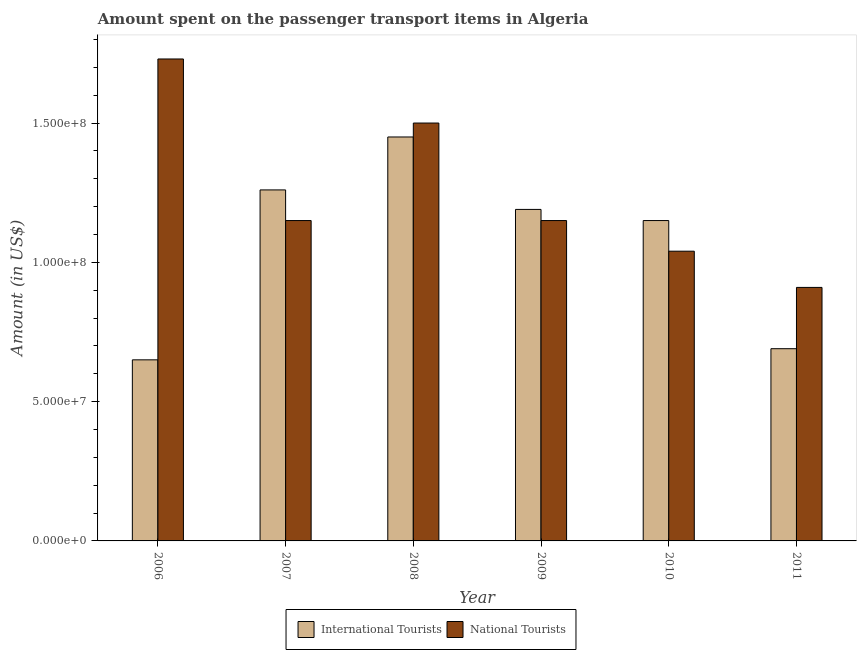How many different coloured bars are there?
Provide a succinct answer. 2. Are the number of bars per tick equal to the number of legend labels?
Ensure brevity in your answer.  Yes. What is the amount spent on transport items of international tourists in 2008?
Your response must be concise. 1.45e+08. Across all years, what is the maximum amount spent on transport items of international tourists?
Make the answer very short. 1.45e+08. Across all years, what is the minimum amount spent on transport items of national tourists?
Keep it short and to the point. 9.10e+07. In which year was the amount spent on transport items of international tourists maximum?
Your response must be concise. 2008. What is the total amount spent on transport items of national tourists in the graph?
Provide a succinct answer. 7.48e+08. What is the difference between the amount spent on transport items of national tourists in 2009 and that in 2011?
Your answer should be compact. 2.40e+07. What is the difference between the amount spent on transport items of international tourists in 2008 and the amount spent on transport items of national tourists in 2007?
Keep it short and to the point. 1.90e+07. What is the average amount spent on transport items of international tourists per year?
Offer a very short reply. 1.06e+08. In how many years, is the amount spent on transport items of national tourists greater than 10000000 US$?
Provide a succinct answer. 6. What is the ratio of the amount spent on transport items of international tourists in 2006 to that in 2007?
Make the answer very short. 0.52. Is the amount spent on transport items of national tourists in 2010 less than that in 2011?
Offer a terse response. No. What is the difference between the highest and the second highest amount spent on transport items of national tourists?
Your answer should be compact. 2.30e+07. What is the difference between the highest and the lowest amount spent on transport items of international tourists?
Keep it short and to the point. 8.00e+07. In how many years, is the amount spent on transport items of international tourists greater than the average amount spent on transport items of international tourists taken over all years?
Ensure brevity in your answer.  4. Is the sum of the amount spent on transport items of international tourists in 2006 and 2007 greater than the maximum amount spent on transport items of national tourists across all years?
Your response must be concise. Yes. What does the 2nd bar from the left in 2009 represents?
Your answer should be compact. National Tourists. What does the 2nd bar from the right in 2007 represents?
Provide a succinct answer. International Tourists. How many years are there in the graph?
Provide a short and direct response. 6. Are the values on the major ticks of Y-axis written in scientific E-notation?
Keep it short and to the point. Yes. Does the graph contain grids?
Provide a succinct answer. No. Where does the legend appear in the graph?
Keep it short and to the point. Bottom center. How many legend labels are there?
Offer a terse response. 2. What is the title of the graph?
Your answer should be compact. Amount spent on the passenger transport items in Algeria. What is the label or title of the X-axis?
Your answer should be compact. Year. What is the label or title of the Y-axis?
Give a very brief answer. Amount (in US$). What is the Amount (in US$) of International Tourists in 2006?
Offer a very short reply. 6.50e+07. What is the Amount (in US$) of National Tourists in 2006?
Offer a very short reply. 1.73e+08. What is the Amount (in US$) in International Tourists in 2007?
Provide a short and direct response. 1.26e+08. What is the Amount (in US$) of National Tourists in 2007?
Make the answer very short. 1.15e+08. What is the Amount (in US$) in International Tourists in 2008?
Ensure brevity in your answer.  1.45e+08. What is the Amount (in US$) in National Tourists in 2008?
Provide a succinct answer. 1.50e+08. What is the Amount (in US$) of International Tourists in 2009?
Offer a very short reply. 1.19e+08. What is the Amount (in US$) in National Tourists in 2009?
Offer a very short reply. 1.15e+08. What is the Amount (in US$) of International Tourists in 2010?
Your answer should be compact. 1.15e+08. What is the Amount (in US$) of National Tourists in 2010?
Make the answer very short. 1.04e+08. What is the Amount (in US$) in International Tourists in 2011?
Keep it short and to the point. 6.90e+07. What is the Amount (in US$) of National Tourists in 2011?
Give a very brief answer. 9.10e+07. Across all years, what is the maximum Amount (in US$) in International Tourists?
Your answer should be very brief. 1.45e+08. Across all years, what is the maximum Amount (in US$) of National Tourists?
Give a very brief answer. 1.73e+08. Across all years, what is the minimum Amount (in US$) of International Tourists?
Offer a very short reply. 6.50e+07. Across all years, what is the minimum Amount (in US$) of National Tourists?
Provide a succinct answer. 9.10e+07. What is the total Amount (in US$) in International Tourists in the graph?
Your answer should be compact. 6.39e+08. What is the total Amount (in US$) of National Tourists in the graph?
Provide a succinct answer. 7.48e+08. What is the difference between the Amount (in US$) in International Tourists in 2006 and that in 2007?
Your answer should be very brief. -6.10e+07. What is the difference between the Amount (in US$) of National Tourists in 2006 and that in 2007?
Give a very brief answer. 5.80e+07. What is the difference between the Amount (in US$) in International Tourists in 2006 and that in 2008?
Provide a succinct answer. -8.00e+07. What is the difference between the Amount (in US$) of National Tourists in 2006 and that in 2008?
Give a very brief answer. 2.30e+07. What is the difference between the Amount (in US$) in International Tourists in 2006 and that in 2009?
Offer a very short reply. -5.40e+07. What is the difference between the Amount (in US$) in National Tourists in 2006 and that in 2009?
Ensure brevity in your answer.  5.80e+07. What is the difference between the Amount (in US$) of International Tourists in 2006 and that in 2010?
Ensure brevity in your answer.  -5.00e+07. What is the difference between the Amount (in US$) of National Tourists in 2006 and that in 2010?
Your answer should be compact. 6.90e+07. What is the difference between the Amount (in US$) in National Tourists in 2006 and that in 2011?
Give a very brief answer. 8.20e+07. What is the difference between the Amount (in US$) in International Tourists in 2007 and that in 2008?
Offer a terse response. -1.90e+07. What is the difference between the Amount (in US$) in National Tourists in 2007 and that in 2008?
Your answer should be compact. -3.50e+07. What is the difference between the Amount (in US$) in National Tourists in 2007 and that in 2009?
Offer a very short reply. 0. What is the difference between the Amount (in US$) of International Tourists in 2007 and that in 2010?
Keep it short and to the point. 1.10e+07. What is the difference between the Amount (in US$) of National Tourists in 2007 and that in 2010?
Your response must be concise. 1.10e+07. What is the difference between the Amount (in US$) of International Tourists in 2007 and that in 2011?
Keep it short and to the point. 5.70e+07. What is the difference between the Amount (in US$) of National Tourists in 2007 and that in 2011?
Give a very brief answer. 2.40e+07. What is the difference between the Amount (in US$) of International Tourists in 2008 and that in 2009?
Make the answer very short. 2.60e+07. What is the difference between the Amount (in US$) in National Tourists in 2008 and that in 2009?
Keep it short and to the point. 3.50e+07. What is the difference between the Amount (in US$) of International Tourists in 2008 and that in 2010?
Offer a terse response. 3.00e+07. What is the difference between the Amount (in US$) in National Tourists in 2008 and that in 2010?
Ensure brevity in your answer.  4.60e+07. What is the difference between the Amount (in US$) in International Tourists in 2008 and that in 2011?
Provide a short and direct response. 7.60e+07. What is the difference between the Amount (in US$) of National Tourists in 2008 and that in 2011?
Your answer should be very brief. 5.90e+07. What is the difference between the Amount (in US$) in National Tourists in 2009 and that in 2010?
Give a very brief answer. 1.10e+07. What is the difference between the Amount (in US$) in International Tourists in 2009 and that in 2011?
Offer a terse response. 5.00e+07. What is the difference between the Amount (in US$) of National Tourists in 2009 and that in 2011?
Keep it short and to the point. 2.40e+07. What is the difference between the Amount (in US$) of International Tourists in 2010 and that in 2011?
Offer a very short reply. 4.60e+07. What is the difference between the Amount (in US$) in National Tourists in 2010 and that in 2011?
Ensure brevity in your answer.  1.30e+07. What is the difference between the Amount (in US$) in International Tourists in 2006 and the Amount (in US$) in National Tourists in 2007?
Offer a terse response. -5.00e+07. What is the difference between the Amount (in US$) of International Tourists in 2006 and the Amount (in US$) of National Tourists in 2008?
Make the answer very short. -8.50e+07. What is the difference between the Amount (in US$) in International Tourists in 2006 and the Amount (in US$) in National Tourists in 2009?
Your answer should be compact. -5.00e+07. What is the difference between the Amount (in US$) of International Tourists in 2006 and the Amount (in US$) of National Tourists in 2010?
Offer a terse response. -3.90e+07. What is the difference between the Amount (in US$) in International Tourists in 2006 and the Amount (in US$) in National Tourists in 2011?
Provide a succinct answer. -2.60e+07. What is the difference between the Amount (in US$) of International Tourists in 2007 and the Amount (in US$) of National Tourists in 2008?
Your answer should be compact. -2.40e+07. What is the difference between the Amount (in US$) of International Tourists in 2007 and the Amount (in US$) of National Tourists in 2009?
Provide a short and direct response. 1.10e+07. What is the difference between the Amount (in US$) of International Tourists in 2007 and the Amount (in US$) of National Tourists in 2010?
Ensure brevity in your answer.  2.20e+07. What is the difference between the Amount (in US$) in International Tourists in 2007 and the Amount (in US$) in National Tourists in 2011?
Your answer should be compact. 3.50e+07. What is the difference between the Amount (in US$) of International Tourists in 2008 and the Amount (in US$) of National Tourists in 2009?
Your answer should be compact. 3.00e+07. What is the difference between the Amount (in US$) in International Tourists in 2008 and the Amount (in US$) in National Tourists in 2010?
Your response must be concise. 4.10e+07. What is the difference between the Amount (in US$) of International Tourists in 2008 and the Amount (in US$) of National Tourists in 2011?
Offer a terse response. 5.40e+07. What is the difference between the Amount (in US$) of International Tourists in 2009 and the Amount (in US$) of National Tourists in 2010?
Give a very brief answer. 1.50e+07. What is the difference between the Amount (in US$) in International Tourists in 2009 and the Amount (in US$) in National Tourists in 2011?
Give a very brief answer. 2.80e+07. What is the difference between the Amount (in US$) in International Tourists in 2010 and the Amount (in US$) in National Tourists in 2011?
Your response must be concise. 2.40e+07. What is the average Amount (in US$) in International Tourists per year?
Ensure brevity in your answer.  1.06e+08. What is the average Amount (in US$) of National Tourists per year?
Offer a very short reply. 1.25e+08. In the year 2006, what is the difference between the Amount (in US$) of International Tourists and Amount (in US$) of National Tourists?
Offer a terse response. -1.08e+08. In the year 2007, what is the difference between the Amount (in US$) of International Tourists and Amount (in US$) of National Tourists?
Offer a very short reply. 1.10e+07. In the year 2008, what is the difference between the Amount (in US$) of International Tourists and Amount (in US$) of National Tourists?
Ensure brevity in your answer.  -5.00e+06. In the year 2009, what is the difference between the Amount (in US$) of International Tourists and Amount (in US$) of National Tourists?
Keep it short and to the point. 4.00e+06. In the year 2010, what is the difference between the Amount (in US$) of International Tourists and Amount (in US$) of National Tourists?
Provide a succinct answer. 1.10e+07. In the year 2011, what is the difference between the Amount (in US$) of International Tourists and Amount (in US$) of National Tourists?
Provide a succinct answer. -2.20e+07. What is the ratio of the Amount (in US$) in International Tourists in 2006 to that in 2007?
Ensure brevity in your answer.  0.52. What is the ratio of the Amount (in US$) in National Tourists in 2006 to that in 2007?
Offer a very short reply. 1.5. What is the ratio of the Amount (in US$) of International Tourists in 2006 to that in 2008?
Offer a very short reply. 0.45. What is the ratio of the Amount (in US$) in National Tourists in 2006 to that in 2008?
Your response must be concise. 1.15. What is the ratio of the Amount (in US$) in International Tourists in 2006 to that in 2009?
Offer a very short reply. 0.55. What is the ratio of the Amount (in US$) of National Tourists in 2006 to that in 2009?
Offer a very short reply. 1.5. What is the ratio of the Amount (in US$) of International Tourists in 2006 to that in 2010?
Provide a short and direct response. 0.57. What is the ratio of the Amount (in US$) in National Tourists in 2006 to that in 2010?
Offer a terse response. 1.66. What is the ratio of the Amount (in US$) in International Tourists in 2006 to that in 2011?
Offer a very short reply. 0.94. What is the ratio of the Amount (in US$) of National Tourists in 2006 to that in 2011?
Your answer should be compact. 1.9. What is the ratio of the Amount (in US$) of International Tourists in 2007 to that in 2008?
Provide a short and direct response. 0.87. What is the ratio of the Amount (in US$) of National Tourists in 2007 to that in 2008?
Offer a terse response. 0.77. What is the ratio of the Amount (in US$) of International Tourists in 2007 to that in 2009?
Ensure brevity in your answer.  1.06. What is the ratio of the Amount (in US$) in International Tourists in 2007 to that in 2010?
Make the answer very short. 1.1. What is the ratio of the Amount (in US$) in National Tourists in 2007 to that in 2010?
Your answer should be compact. 1.11. What is the ratio of the Amount (in US$) of International Tourists in 2007 to that in 2011?
Offer a terse response. 1.83. What is the ratio of the Amount (in US$) of National Tourists in 2007 to that in 2011?
Your response must be concise. 1.26. What is the ratio of the Amount (in US$) in International Tourists in 2008 to that in 2009?
Your response must be concise. 1.22. What is the ratio of the Amount (in US$) in National Tourists in 2008 to that in 2009?
Provide a short and direct response. 1.3. What is the ratio of the Amount (in US$) in International Tourists in 2008 to that in 2010?
Give a very brief answer. 1.26. What is the ratio of the Amount (in US$) of National Tourists in 2008 to that in 2010?
Your response must be concise. 1.44. What is the ratio of the Amount (in US$) of International Tourists in 2008 to that in 2011?
Your answer should be very brief. 2.1. What is the ratio of the Amount (in US$) of National Tourists in 2008 to that in 2011?
Provide a short and direct response. 1.65. What is the ratio of the Amount (in US$) of International Tourists in 2009 to that in 2010?
Make the answer very short. 1.03. What is the ratio of the Amount (in US$) of National Tourists in 2009 to that in 2010?
Make the answer very short. 1.11. What is the ratio of the Amount (in US$) in International Tourists in 2009 to that in 2011?
Provide a succinct answer. 1.72. What is the ratio of the Amount (in US$) of National Tourists in 2009 to that in 2011?
Make the answer very short. 1.26. What is the difference between the highest and the second highest Amount (in US$) of International Tourists?
Make the answer very short. 1.90e+07. What is the difference between the highest and the second highest Amount (in US$) in National Tourists?
Offer a terse response. 2.30e+07. What is the difference between the highest and the lowest Amount (in US$) in International Tourists?
Give a very brief answer. 8.00e+07. What is the difference between the highest and the lowest Amount (in US$) of National Tourists?
Keep it short and to the point. 8.20e+07. 